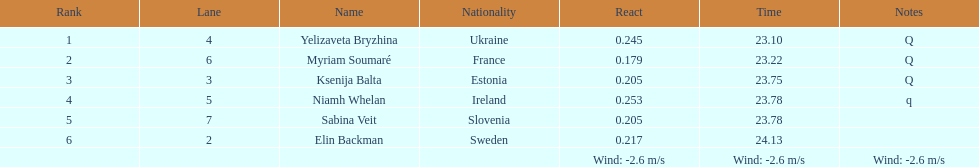Which player is from ireland? Niamh Whelan. 